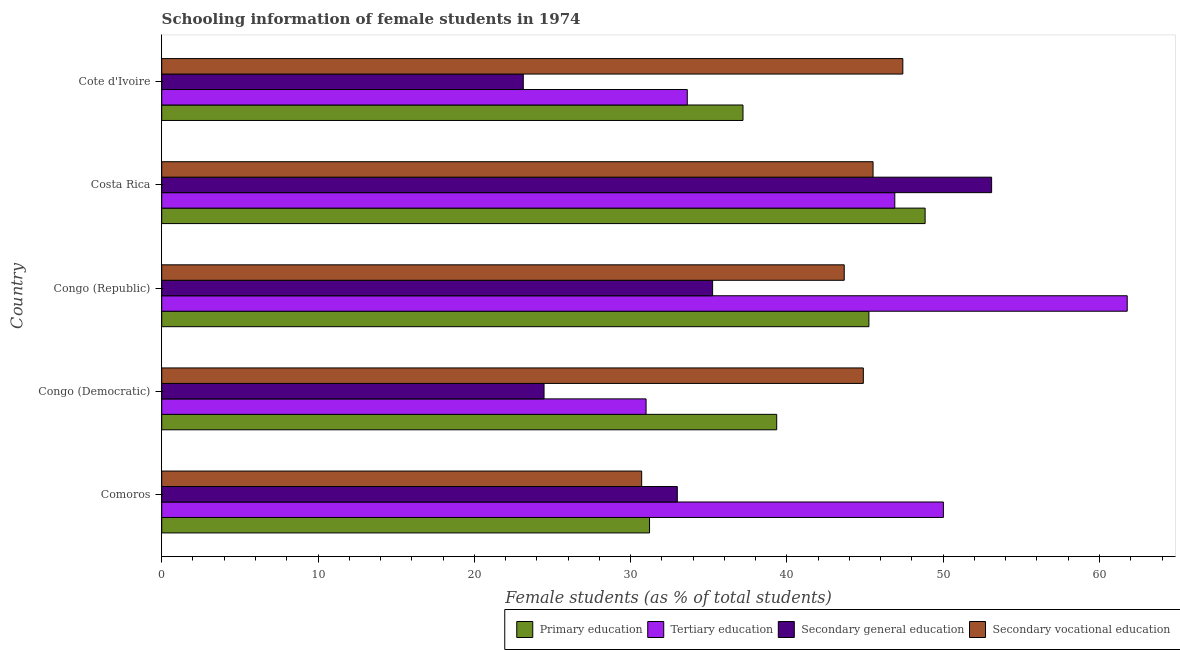How many different coloured bars are there?
Your answer should be compact. 4. How many groups of bars are there?
Offer a very short reply. 5. Are the number of bars per tick equal to the number of legend labels?
Provide a succinct answer. Yes. Are the number of bars on each tick of the Y-axis equal?
Give a very brief answer. Yes. How many bars are there on the 1st tick from the top?
Provide a succinct answer. 4. How many bars are there on the 4th tick from the bottom?
Offer a terse response. 4. What is the label of the 2nd group of bars from the top?
Provide a succinct answer. Costa Rica. What is the percentage of female students in secondary education in Congo (Democratic)?
Your answer should be compact. 24.46. Across all countries, what is the maximum percentage of female students in secondary vocational education?
Offer a terse response. 47.42. Across all countries, what is the minimum percentage of female students in tertiary education?
Ensure brevity in your answer.  30.99. In which country was the percentage of female students in primary education maximum?
Provide a short and direct response. Costa Rica. In which country was the percentage of female students in secondary vocational education minimum?
Your answer should be very brief. Comoros. What is the total percentage of female students in primary education in the graph?
Your response must be concise. 201.84. What is the difference between the percentage of female students in primary education in Comoros and that in Cote d'Ivoire?
Keep it short and to the point. -5.98. What is the difference between the percentage of female students in secondary education in Congo (Democratic) and the percentage of female students in tertiary education in Congo (Republic)?
Provide a succinct answer. -37.31. What is the average percentage of female students in tertiary education per country?
Keep it short and to the point. 44.66. What is the difference between the percentage of female students in primary education and percentage of female students in tertiary education in Congo (Democratic)?
Provide a short and direct response. 8.36. What is the ratio of the percentage of female students in tertiary education in Congo (Democratic) to that in Congo (Republic)?
Your answer should be compact. 0.5. Is the percentage of female students in secondary education in Comoros less than that in Congo (Democratic)?
Ensure brevity in your answer.  No. Is the difference between the percentage of female students in tertiary education in Congo (Republic) and Costa Rica greater than the difference between the percentage of female students in primary education in Congo (Republic) and Costa Rica?
Offer a very short reply. Yes. What is the difference between the highest and the second highest percentage of female students in secondary education?
Ensure brevity in your answer.  17.85. What is the difference between the highest and the lowest percentage of female students in secondary vocational education?
Give a very brief answer. 16.71. In how many countries, is the percentage of female students in secondary vocational education greater than the average percentage of female students in secondary vocational education taken over all countries?
Your answer should be very brief. 4. Is it the case that in every country, the sum of the percentage of female students in secondary vocational education and percentage of female students in tertiary education is greater than the sum of percentage of female students in primary education and percentage of female students in secondary education?
Provide a succinct answer. No. What does the 4th bar from the top in Costa Rica represents?
Provide a succinct answer. Primary education. What does the 3rd bar from the bottom in Cote d'Ivoire represents?
Give a very brief answer. Secondary general education. Is it the case that in every country, the sum of the percentage of female students in primary education and percentage of female students in tertiary education is greater than the percentage of female students in secondary education?
Provide a short and direct response. Yes. How many bars are there?
Your answer should be compact. 20. Are all the bars in the graph horizontal?
Your response must be concise. Yes. How many legend labels are there?
Your response must be concise. 4. What is the title of the graph?
Offer a very short reply. Schooling information of female students in 1974. Does "Services" appear as one of the legend labels in the graph?
Make the answer very short. No. What is the label or title of the X-axis?
Give a very brief answer. Female students (as % of total students). What is the Female students (as % of total students) of Primary education in Comoros?
Provide a short and direct response. 31.21. What is the Female students (as % of total students) of Tertiary education in Comoros?
Offer a very short reply. 50.01. What is the Female students (as % of total students) of Secondary general education in Comoros?
Keep it short and to the point. 32.99. What is the Female students (as % of total students) in Secondary vocational education in Comoros?
Offer a very short reply. 30.71. What is the Female students (as % of total students) in Primary education in Congo (Democratic)?
Keep it short and to the point. 39.35. What is the Female students (as % of total students) of Tertiary education in Congo (Democratic)?
Your response must be concise. 30.99. What is the Female students (as % of total students) of Secondary general education in Congo (Democratic)?
Ensure brevity in your answer.  24.46. What is the Female students (as % of total students) of Secondary vocational education in Congo (Democratic)?
Ensure brevity in your answer.  44.89. What is the Female students (as % of total students) of Primary education in Congo (Republic)?
Give a very brief answer. 45.25. What is the Female students (as % of total students) in Tertiary education in Congo (Republic)?
Provide a short and direct response. 61.77. What is the Female students (as % of total students) of Secondary general education in Congo (Republic)?
Provide a short and direct response. 35.25. What is the Female students (as % of total students) of Secondary vocational education in Congo (Republic)?
Your answer should be very brief. 43.67. What is the Female students (as % of total students) in Primary education in Costa Rica?
Keep it short and to the point. 48.84. What is the Female students (as % of total students) of Tertiary education in Costa Rica?
Give a very brief answer. 46.9. What is the Female students (as % of total students) in Secondary general education in Costa Rica?
Offer a terse response. 53.1. What is the Female students (as % of total students) in Secondary vocational education in Costa Rica?
Your answer should be very brief. 45.51. What is the Female students (as % of total students) in Primary education in Cote d'Ivoire?
Keep it short and to the point. 37.19. What is the Female students (as % of total students) in Tertiary education in Cote d'Ivoire?
Give a very brief answer. 33.63. What is the Female students (as % of total students) in Secondary general education in Cote d'Ivoire?
Your answer should be very brief. 23.13. What is the Female students (as % of total students) of Secondary vocational education in Cote d'Ivoire?
Provide a succinct answer. 47.42. Across all countries, what is the maximum Female students (as % of total students) of Primary education?
Provide a succinct answer. 48.84. Across all countries, what is the maximum Female students (as % of total students) in Tertiary education?
Keep it short and to the point. 61.77. Across all countries, what is the maximum Female students (as % of total students) in Secondary general education?
Offer a very short reply. 53.1. Across all countries, what is the maximum Female students (as % of total students) of Secondary vocational education?
Your response must be concise. 47.42. Across all countries, what is the minimum Female students (as % of total students) in Primary education?
Offer a very short reply. 31.21. Across all countries, what is the minimum Female students (as % of total students) of Tertiary education?
Your answer should be compact. 30.99. Across all countries, what is the minimum Female students (as % of total students) in Secondary general education?
Your response must be concise. 23.13. Across all countries, what is the minimum Female students (as % of total students) in Secondary vocational education?
Your response must be concise. 30.71. What is the total Female students (as % of total students) of Primary education in the graph?
Ensure brevity in your answer.  201.84. What is the total Female students (as % of total students) in Tertiary education in the graph?
Offer a very short reply. 223.3. What is the total Female students (as % of total students) of Secondary general education in the graph?
Your answer should be very brief. 168.93. What is the total Female students (as % of total students) of Secondary vocational education in the graph?
Offer a very short reply. 212.19. What is the difference between the Female students (as % of total students) in Primary education in Comoros and that in Congo (Democratic)?
Your answer should be very brief. -8.14. What is the difference between the Female students (as % of total students) of Tertiary education in Comoros and that in Congo (Democratic)?
Ensure brevity in your answer.  19.02. What is the difference between the Female students (as % of total students) in Secondary general education in Comoros and that in Congo (Democratic)?
Your answer should be very brief. 8.53. What is the difference between the Female students (as % of total students) of Secondary vocational education in Comoros and that in Congo (Democratic)?
Ensure brevity in your answer.  -14.18. What is the difference between the Female students (as % of total students) of Primary education in Comoros and that in Congo (Republic)?
Keep it short and to the point. -14.04. What is the difference between the Female students (as % of total students) in Tertiary education in Comoros and that in Congo (Republic)?
Offer a terse response. -11.76. What is the difference between the Female students (as % of total students) in Secondary general education in Comoros and that in Congo (Republic)?
Provide a succinct answer. -2.26. What is the difference between the Female students (as % of total students) in Secondary vocational education in Comoros and that in Congo (Republic)?
Provide a short and direct response. -12.96. What is the difference between the Female students (as % of total students) in Primary education in Comoros and that in Costa Rica?
Offer a terse response. -17.63. What is the difference between the Female students (as % of total students) in Tertiary education in Comoros and that in Costa Rica?
Provide a succinct answer. 3.11. What is the difference between the Female students (as % of total students) in Secondary general education in Comoros and that in Costa Rica?
Your response must be concise. -20.11. What is the difference between the Female students (as % of total students) in Secondary vocational education in Comoros and that in Costa Rica?
Make the answer very short. -14.8. What is the difference between the Female students (as % of total students) of Primary education in Comoros and that in Cote d'Ivoire?
Provide a succinct answer. -5.98. What is the difference between the Female students (as % of total students) in Tertiary education in Comoros and that in Cote d'Ivoire?
Provide a succinct answer. 16.39. What is the difference between the Female students (as % of total students) in Secondary general education in Comoros and that in Cote d'Ivoire?
Offer a very short reply. 9.85. What is the difference between the Female students (as % of total students) in Secondary vocational education in Comoros and that in Cote d'Ivoire?
Ensure brevity in your answer.  -16.71. What is the difference between the Female students (as % of total students) of Primary education in Congo (Democratic) and that in Congo (Republic)?
Your answer should be very brief. -5.9. What is the difference between the Female students (as % of total students) of Tertiary education in Congo (Democratic) and that in Congo (Republic)?
Provide a succinct answer. -30.78. What is the difference between the Female students (as % of total students) of Secondary general education in Congo (Democratic) and that in Congo (Republic)?
Provide a succinct answer. -10.79. What is the difference between the Female students (as % of total students) of Secondary vocational education in Congo (Democratic) and that in Congo (Republic)?
Give a very brief answer. 1.22. What is the difference between the Female students (as % of total students) of Primary education in Congo (Democratic) and that in Costa Rica?
Make the answer very short. -9.5. What is the difference between the Female students (as % of total students) of Tertiary education in Congo (Democratic) and that in Costa Rica?
Provide a succinct answer. -15.91. What is the difference between the Female students (as % of total students) in Secondary general education in Congo (Democratic) and that in Costa Rica?
Ensure brevity in your answer.  -28.64. What is the difference between the Female students (as % of total students) of Secondary vocational education in Congo (Democratic) and that in Costa Rica?
Make the answer very short. -0.62. What is the difference between the Female students (as % of total students) of Primary education in Congo (Democratic) and that in Cote d'Ivoire?
Your response must be concise. 2.16. What is the difference between the Female students (as % of total students) of Tertiary education in Congo (Democratic) and that in Cote d'Ivoire?
Ensure brevity in your answer.  -2.64. What is the difference between the Female students (as % of total students) in Secondary general education in Congo (Democratic) and that in Cote d'Ivoire?
Your answer should be very brief. 1.33. What is the difference between the Female students (as % of total students) in Secondary vocational education in Congo (Democratic) and that in Cote d'Ivoire?
Your answer should be compact. -2.53. What is the difference between the Female students (as % of total students) of Primary education in Congo (Republic) and that in Costa Rica?
Give a very brief answer. -3.6. What is the difference between the Female students (as % of total students) of Tertiary education in Congo (Republic) and that in Costa Rica?
Ensure brevity in your answer.  14.87. What is the difference between the Female students (as % of total students) of Secondary general education in Congo (Republic) and that in Costa Rica?
Ensure brevity in your answer.  -17.85. What is the difference between the Female students (as % of total students) in Secondary vocational education in Congo (Republic) and that in Costa Rica?
Provide a succinct answer. -1.84. What is the difference between the Female students (as % of total students) of Primary education in Congo (Republic) and that in Cote d'Ivoire?
Ensure brevity in your answer.  8.06. What is the difference between the Female students (as % of total students) of Tertiary education in Congo (Republic) and that in Cote d'Ivoire?
Make the answer very short. 28.15. What is the difference between the Female students (as % of total students) in Secondary general education in Congo (Republic) and that in Cote d'Ivoire?
Make the answer very short. 12.11. What is the difference between the Female students (as % of total students) of Secondary vocational education in Congo (Republic) and that in Cote d'Ivoire?
Ensure brevity in your answer.  -3.75. What is the difference between the Female students (as % of total students) of Primary education in Costa Rica and that in Cote d'Ivoire?
Keep it short and to the point. 11.65. What is the difference between the Female students (as % of total students) in Tertiary education in Costa Rica and that in Cote d'Ivoire?
Make the answer very short. 13.28. What is the difference between the Female students (as % of total students) of Secondary general education in Costa Rica and that in Cote d'Ivoire?
Offer a terse response. 29.96. What is the difference between the Female students (as % of total students) in Secondary vocational education in Costa Rica and that in Cote d'Ivoire?
Your response must be concise. -1.9. What is the difference between the Female students (as % of total students) in Primary education in Comoros and the Female students (as % of total students) in Tertiary education in Congo (Democratic)?
Give a very brief answer. 0.22. What is the difference between the Female students (as % of total students) of Primary education in Comoros and the Female students (as % of total students) of Secondary general education in Congo (Democratic)?
Give a very brief answer. 6.75. What is the difference between the Female students (as % of total students) in Primary education in Comoros and the Female students (as % of total students) in Secondary vocational education in Congo (Democratic)?
Provide a succinct answer. -13.68. What is the difference between the Female students (as % of total students) in Tertiary education in Comoros and the Female students (as % of total students) in Secondary general education in Congo (Democratic)?
Provide a succinct answer. 25.55. What is the difference between the Female students (as % of total students) of Tertiary education in Comoros and the Female students (as % of total students) of Secondary vocational education in Congo (Democratic)?
Offer a terse response. 5.12. What is the difference between the Female students (as % of total students) of Secondary general education in Comoros and the Female students (as % of total students) of Secondary vocational education in Congo (Democratic)?
Ensure brevity in your answer.  -11.9. What is the difference between the Female students (as % of total students) of Primary education in Comoros and the Female students (as % of total students) of Tertiary education in Congo (Republic)?
Offer a terse response. -30.56. What is the difference between the Female students (as % of total students) in Primary education in Comoros and the Female students (as % of total students) in Secondary general education in Congo (Republic)?
Your answer should be very brief. -4.04. What is the difference between the Female students (as % of total students) of Primary education in Comoros and the Female students (as % of total students) of Secondary vocational education in Congo (Republic)?
Your answer should be compact. -12.46. What is the difference between the Female students (as % of total students) of Tertiary education in Comoros and the Female students (as % of total students) of Secondary general education in Congo (Republic)?
Ensure brevity in your answer.  14.76. What is the difference between the Female students (as % of total students) of Tertiary education in Comoros and the Female students (as % of total students) of Secondary vocational education in Congo (Republic)?
Make the answer very short. 6.34. What is the difference between the Female students (as % of total students) of Secondary general education in Comoros and the Female students (as % of total students) of Secondary vocational education in Congo (Republic)?
Make the answer very short. -10.68. What is the difference between the Female students (as % of total students) of Primary education in Comoros and the Female students (as % of total students) of Tertiary education in Costa Rica?
Offer a terse response. -15.69. What is the difference between the Female students (as % of total students) in Primary education in Comoros and the Female students (as % of total students) in Secondary general education in Costa Rica?
Make the answer very short. -21.89. What is the difference between the Female students (as % of total students) of Primary education in Comoros and the Female students (as % of total students) of Secondary vocational education in Costa Rica?
Your response must be concise. -14.3. What is the difference between the Female students (as % of total students) of Tertiary education in Comoros and the Female students (as % of total students) of Secondary general education in Costa Rica?
Make the answer very short. -3.09. What is the difference between the Female students (as % of total students) in Tertiary education in Comoros and the Female students (as % of total students) in Secondary vocational education in Costa Rica?
Provide a short and direct response. 4.5. What is the difference between the Female students (as % of total students) of Secondary general education in Comoros and the Female students (as % of total students) of Secondary vocational education in Costa Rica?
Make the answer very short. -12.52. What is the difference between the Female students (as % of total students) in Primary education in Comoros and the Female students (as % of total students) in Tertiary education in Cote d'Ivoire?
Your response must be concise. -2.42. What is the difference between the Female students (as % of total students) of Primary education in Comoros and the Female students (as % of total students) of Secondary general education in Cote d'Ivoire?
Provide a short and direct response. 8.08. What is the difference between the Female students (as % of total students) in Primary education in Comoros and the Female students (as % of total students) in Secondary vocational education in Cote d'Ivoire?
Offer a terse response. -16.21. What is the difference between the Female students (as % of total students) in Tertiary education in Comoros and the Female students (as % of total students) in Secondary general education in Cote d'Ivoire?
Give a very brief answer. 26.88. What is the difference between the Female students (as % of total students) in Tertiary education in Comoros and the Female students (as % of total students) in Secondary vocational education in Cote d'Ivoire?
Your answer should be compact. 2.59. What is the difference between the Female students (as % of total students) in Secondary general education in Comoros and the Female students (as % of total students) in Secondary vocational education in Cote d'Ivoire?
Provide a short and direct response. -14.43. What is the difference between the Female students (as % of total students) in Primary education in Congo (Democratic) and the Female students (as % of total students) in Tertiary education in Congo (Republic)?
Ensure brevity in your answer.  -22.43. What is the difference between the Female students (as % of total students) of Primary education in Congo (Democratic) and the Female students (as % of total students) of Secondary general education in Congo (Republic)?
Make the answer very short. 4.1. What is the difference between the Female students (as % of total students) in Primary education in Congo (Democratic) and the Female students (as % of total students) in Secondary vocational education in Congo (Republic)?
Offer a very short reply. -4.32. What is the difference between the Female students (as % of total students) of Tertiary education in Congo (Democratic) and the Female students (as % of total students) of Secondary general education in Congo (Republic)?
Your answer should be compact. -4.26. What is the difference between the Female students (as % of total students) of Tertiary education in Congo (Democratic) and the Female students (as % of total students) of Secondary vocational education in Congo (Republic)?
Your answer should be compact. -12.68. What is the difference between the Female students (as % of total students) in Secondary general education in Congo (Democratic) and the Female students (as % of total students) in Secondary vocational education in Congo (Republic)?
Make the answer very short. -19.21. What is the difference between the Female students (as % of total students) of Primary education in Congo (Democratic) and the Female students (as % of total students) of Tertiary education in Costa Rica?
Ensure brevity in your answer.  -7.56. What is the difference between the Female students (as % of total students) in Primary education in Congo (Democratic) and the Female students (as % of total students) in Secondary general education in Costa Rica?
Ensure brevity in your answer.  -13.75. What is the difference between the Female students (as % of total students) of Primary education in Congo (Democratic) and the Female students (as % of total students) of Secondary vocational education in Costa Rica?
Make the answer very short. -6.17. What is the difference between the Female students (as % of total students) in Tertiary education in Congo (Democratic) and the Female students (as % of total students) in Secondary general education in Costa Rica?
Keep it short and to the point. -22.11. What is the difference between the Female students (as % of total students) in Tertiary education in Congo (Democratic) and the Female students (as % of total students) in Secondary vocational education in Costa Rica?
Provide a short and direct response. -14.52. What is the difference between the Female students (as % of total students) of Secondary general education in Congo (Democratic) and the Female students (as % of total students) of Secondary vocational education in Costa Rica?
Offer a very short reply. -21.05. What is the difference between the Female students (as % of total students) of Primary education in Congo (Democratic) and the Female students (as % of total students) of Tertiary education in Cote d'Ivoire?
Provide a short and direct response. 5.72. What is the difference between the Female students (as % of total students) of Primary education in Congo (Democratic) and the Female students (as % of total students) of Secondary general education in Cote d'Ivoire?
Make the answer very short. 16.21. What is the difference between the Female students (as % of total students) of Primary education in Congo (Democratic) and the Female students (as % of total students) of Secondary vocational education in Cote d'Ivoire?
Provide a short and direct response. -8.07. What is the difference between the Female students (as % of total students) of Tertiary education in Congo (Democratic) and the Female students (as % of total students) of Secondary general education in Cote d'Ivoire?
Offer a terse response. 7.86. What is the difference between the Female students (as % of total students) of Tertiary education in Congo (Democratic) and the Female students (as % of total students) of Secondary vocational education in Cote d'Ivoire?
Your answer should be compact. -16.43. What is the difference between the Female students (as % of total students) of Secondary general education in Congo (Democratic) and the Female students (as % of total students) of Secondary vocational education in Cote d'Ivoire?
Make the answer very short. -22.96. What is the difference between the Female students (as % of total students) of Primary education in Congo (Republic) and the Female students (as % of total students) of Tertiary education in Costa Rica?
Ensure brevity in your answer.  -1.66. What is the difference between the Female students (as % of total students) in Primary education in Congo (Republic) and the Female students (as % of total students) in Secondary general education in Costa Rica?
Provide a succinct answer. -7.85. What is the difference between the Female students (as % of total students) of Primary education in Congo (Republic) and the Female students (as % of total students) of Secondary vocational education in Costa Rica?
Your answer should be compact. -0.27. What is the difference between the Female students (as % of total students) of Tertiary education in Congo (Republic) and the Female students (as % of total students) of Secondary general education in Costa Rica?
Your answer should be very brief. 8.68. What is the difference between the Female students (as % of total students) of Tertiary education in Congo (Republic) and the Female students (as % of total students) of Secondary vocational education in Costa Rica?
Provide a succinct answer. 16.26. What is the difference between the Female students (as % of total students) in Secondary general education in Congo (Republic) and the Female students (as % of total students) in Secondary vocational education in Costa Rica?
Give a very brief answer. -10.27. What is the difference between the Female students (as % of total students) of Primary education in Congo (Republic) and the Female students (as % of total students) of Tertiary education in Cote d'Ivoire?
Provide a short and direct response. 11.62. What is the difference between the Female students (as % of total students) of Primary education in Congo (Republic) and the Female students (as % of total students) of Secondary general education in Cote d'Ivoire?
Keep it short and to the point. 22.11. What is the difference between the Female students (as % of total students) in Primary education in Congo (Republic) and the Female students (as % of total students) in Secondary vocational education in Cote d'Ivoire?
Offer a very short reply. -2.17. What is the difference between the Female students (as % of total students) of Tertiary education in Congo (Republic) and the Female students (as % of total students) of Secondary general education in Cote d'Ivoire?
Offer a terse response. 38.64. What is the difference between the Female students (as % of total students) in Tertiary education in Congo (Republic) and the Female students (as % of total students) in Secondary vocational education in Cote d'Ivoire?
Make the answer very short. 14.36. What is the difference between the Female students (as % of total students) in Secondary general education in Congo (Republic) and the Female students (as % of total students) in Secondary vocational education in Cote d'Ivoire?
Make the answer very short. -12.17. What is the difference between the Female students (as % of total students) in Primary education in Costa Rica and the Female students (as % of total students) in Tertiary education in Cote d'Ivoire?
Your response must be concise. 15.22. What is the difference between the Female students (as % of total students) in Primary education in Costa Rica and the Female students (as % of total students) in Secondary general education in Cote d'Ivoire?
Ensure brevity in your answer.  25.71. What is the difference between the Female students (as % of total students) of Primary education in Costa Rica and the Female students (as % of total students) of Secondary vocational education in Cote d'Ivoire?
Give a very brief answer. 1.43. What is the difference between the Female students (as % of total students) in Tertiary education in Costa Rica and the Female students (as % of total students) in Secondary general education in Cote d'Ivoire?
Your response must be concise. 23.77. What is the difference between the Female students (as % of total students) of Tertiary education in Costa Rica and the Female students (as % of total students) of Secondary vocational education in Cote d'Ivoire?
Your answer should be compact. -0.51. What is the difference between the Female students (as % of total students) of Secondary general education in Costa Rica and the Female students (as % of total students) of Secondary vocational education in Cote d'Ivoire?
Make the answer very short. 5.68. What is the average Female students (as % of total students) of Primary education per country?
Make the answer very short. 40.37. What is the average Female students (as % of total students) of Tertiary education per country?
Give a very brief answer. 44.66. What is the average Female students (as % of total students) in Secondary general education per country?
Your response must be concise. 33.79. What is the average Female students (as % of total students) of Secondary vocational education per country?
Your answer should be very brief. 42.44. What is the difference between the Female students (as % of total students) in Primary education and Female students (as % of total students) in Tertiary education in Comoros?
Your answer should be very brief. -18.8. What is the difference between the Female students (as % of total students) of Primary education and Female students (as % of total students) of Secondary general education in Comoros?
Make the answer very short. -1.78. What is the difference between the Female students (as % of total students) in Primary education and Female students (as % of total students) in Secondary vocational education in Comoros?
Your answer should be very brief. 0.5. What is the difference between the Female students (as % of total students) in Tertiary education and Female students (as % of total students) in Secondary general education in Comoros?
Your response must be concise. 17.02. What is the difference between the Female students (as % of total students) in Tertiary education and Female students (as % of total students) in Secondary vocational education in Comoros?
Your response must be concise. 19.3. What is the difference between the Female students (as % of total students) in Secondary general education and Female students (as % of total students) in Secondary vocational education in Comoros?
Give a very brief answer. 2.28. What is the difference between the Female students (as % of total students) of Primary education and Female students (as % of total students) of Tertiary education in Congo (Democratic)?
Make the answer very short. 8.36. What is the difference between the Female students (as % of total students) in Primary education and Female students (as % of total students) in Secondary general education in Congo (Democratic)?
Give a very brief answer. 14.89. What is the difference between the Female students (as % of total students) in Primary education and Female students (as % of total students) in Secondary vocational education in Congo (Democratic)?
Give a very brief answer. -5.54. What is the difference between the Female students (as % of total students) of Tertiary education and Female students (as % of total students) of Secondary general education in Congo (Democratic)?
Provide a succinct answer. 6.53. What is the difference between the Female students (as % of total students) in Tertiary education and Female students (as % of total students) in Secondary vocational education in Congo (Democratic)?
Your response must be concise. -13.9. What is the difference between the Female students (as % of total students) of Secondary general education and Female students (as % of total students) of Secondary vocational education in Congo (Democratic)?
Offer a very short reply. -20.43. What is the difference between the Female students (as % of total students) of Primary education and Female students (as % of total students) of Tertiary education in Congo (Republic)?
Give a very brief answer. -16.53. What is the difference between the Female students (as % of total students) of Primary education and Female students (as % of total students) of Secondary general education in Congo (Republic)?
Give a very brief answer. 10. What is the difference between the Female students (as % of total students) of Primary education and Female students (as % of total students) of Secondary vocational education in Congo (Republic)?
Keep it short and to the point. 1.58. What is the difference between the Female students (as % of total students) in Tertiary education and Female students (as % of total students) in Secondary general education in Congo (Republic)?
Offer a terse response. 26.53. What is the difference between the Female students (as % of total students) of Tertiary education and Female students (as % of total students) of Secondary vocational education in Congo (Republic)?
Give a very brief answer. 18.11. What is the difference between the Female students (as % of total students) in Secondary general education and Female students (as % of total students) in Secondary vocational education in Congo (Republic)?
Your answer should be compact. -8.42. What is the difference between the Female students (as % of total students) of Primary education and Female students (as % of total students) of Tertiary education in Costa Rica?
Offer a very short reply. 1.94. What is the difference between the Female students (as % of total students) of Primary education and Female students (as % of total students) of Secondary general education in Costa Rica?
Your answer should be very brief. -4.26. What is the difference between the Female students (as % of total students) in Primary education and Female students (as % of total students) in Secondary vocational education in Costa Rica?
Offer a terse response. 3.33. What is the difference between the Female students (as % of total students) in Tertiary education and Female students (as % of total students) in Secondary general education in Costa Rica?
Provide a succinct answer. -6.19. What is the difference between the Female students (as % of total students) in Tertiary education and Female students (as % of total students) in Secondary vocational education in Costa Rica?
Offer a terse response. 1.39. What is the difference between the Female students (as % of total students) in Secondary general education and Female students (as % of total students) in Secondary vocational education in Costa Rica?
Your response must be concise. 7.59. What is the difference between the Female students (as % of total students) of Primary education and Female students (as % of total students) of Tertiary education in Cote d'Ivoire?
Provide a short and direct response. 3.56. What is the difference between the Female students (as % of total students) in Primary education and Female students (as % of total students) in Secondary general education in Cote d'Ivoire?
Your response must be concise. 14.06. What is the difference between the Female students (as % of total students) in Primary education and Female students (as % of total students) in Secondary vocational education in Cote d'Ivoire?
Your answer should be compact. -10.23. What is the difference between the Female students (as % of total students) in Tertiary education and Female students (as % of total students) in Secondary general education in Cote d'Ivoire?
Provide a short and direct response. 10.49. What is the difference between the Female students (as % of total students) in Tertiary education and Female students (as % of total students) in Secondary vocational education in Cote d'Ivoire?
Provide a succinct answer. -13.79. What is the difference between the Female students (as % of total students) of Secondary general education and Female students (as % of total students) of Secondary vocational education in Cote d'Ivoire?
Make the answer very short. -24.28. What is the ratio of the Female students (as % of total students) in Primary education in Comoros to that in Congo (Democratic)?
Provide a succinct answer. 0.79. What is the ratio of the Female students (as % of total students) in Tertiary education in Comoros to that in Congo (Democratic)?
Your answer should be very brief. 1.61. What is the ratio of the Female students (as % of total students) of Secondary general education in Comoros to that in Congo (Democratic)?
Ensure brevity in your answer.  1.35. What is the ratio of the Female students (as % of total students) of Secondary vocational education in Comoros to that in Congo (Democratic)?
Your answer should be very brief. 0.68. What is the ratio of the Female students (as % of total students) of Primary education in Comoros to that in Congo (Republic)?
Provide a short and direct response. 0.69. What is the ratio of the Female students (as % of total students) in Tertiary education in Comoros to that in Congo (Republic)?
Provide a succinct answer. 0.81. What is the ratio of the Female students (as % of total students) of Secondary general education in Comoros to that in Congo (Republic)?
Your answer should be very brief. 0.94. What is the ratio of the Female students (as % of total students) of Secondary vocational education in Comoros to that in Congo (Republic)?
Provide a succinct answer. 0.7. What is the ratio of the Female students (as % of total students) of Primary education in Comoros to that in Costa Rica?
Your answer should be compact. 0.64. What is the ratio of the Female students (as % of total students) in Tertiary education in Comoros to that in Costa Rica?
Provide a succinct answer. 1.07. What is the ratio of the Female students (as % of total students) of Secondary general education in Comoros to that in Costa Rica?
Your response must be concise. 0.62. What is the ratio of the Female students (as % of total students) in Secondary vocational education in Comoros to that in Costa Rica?
Provide a succinct answer. 0.67. What is the ratio of the Female students (as % of total students) of Primary education in Comoros to that in Cote d'Ivoire?
Make the answer very short. 0.84. What is the ratio of the Female students (as % of total students) of Tertiary education in Comoros to that in Cote d'Ivoire?
Your response must be concise. 1.49. What is the ratio of the Female students (as % of total students) of Secondary general education in Comoros to that in Cote d'Ivoire?
Your response must be concise. 1.43. What is the ratio of the Female students (as % of total students) of Secondary vocational education in Comoros to that in Cote d'Ivoire?
Your answer should be compact. 0.65. What is the ratio of the Female students (as % of total students) in Primary education in Congo (Democratic) to that in Congo (Republic)?
Provide a succinct answer. 0.87. What is the ratio of the Female students (as % of total students) of Tertiary education in Congo (Democratic) to that in Congo (Republic)?
Keep it short and to the point. 0.5. What is the ratio of the Female students (as % of total students) in Secondary general education in Congo (Democratic) to that in Congo (Republic)?
Keep it short and to the point. 0.69. What is the ratio of the Female students (as % of total students) of Secondary vocational education in Congo (Democratic) to that in Congo (Republic)?
Your answer should be very brief. 1.03. What is the ratio of the Female students (as % of total students) in Primary education in Congo (Democratic) to that in Costa Rica?
Your answer should be compact. 0.81. What is the ratio of the Female students (as % of total students) in Tertiary education in Congo (Democratic) to that in Costa Rica?
Give a very brief answer. 0.66. What is the ratio of the Female students (as % of total students) of Secondary general education in Congo (Democratic) to that in Costa Rica?
Provide a short and direct response. 0.46. What is the ratio of the Female students (as % of total students) in Secondary vocational education in Congo (Democratic) to that in Costa Rica?
Your answer should be compact. 0.99. What is the ratio of the Female students (as % of total students) in Primary education in Congo (Democratic) to that in Cote d'Ivoire?
Offer a terse response. 1.06. What is the ratio of the Female students (as % of total students) of Tertiary education in Congo (Democratic) to that in Cote d'Ivoire?
Offer a very short reply. 0.92. What is the ratio of the Female students (as % of total students) in Secondary general education in Congo (Democratic) to that in Cote d'Ivoire?
Your answer should be compact. 1.06. What is the ratio of the Female students (as % of total students) in Secondary vocational education in Congo (Democratic) to that in Cote d'Ivoire?
Provide a short and direct response. 0.95. What is the ratio of the Female students (as % of total students) in Primary education in Congo (Republic) to that in Costa Rica?
Your answer should be very brief. 0.93. What is the ratio of the Female students (as % of total students) of Tertiary education in Congo (Republic) to that in Costa Rica?
Your answer should be very brief. 1.32. What is the ratio of the Female students (as % of total students) in Secondary general education in Congo (Republic) to that in Costa Rica?
Provide a short and direct response. 0.66. What is the ratio of the Female students (as % of total students) in Secondary vocational education in Congo (Republic) to that in Costa Rica?
Keep it short and to the point. 0.96. What is the ratio of the Female students (as % of total students) of Primary education in Congo (Republic) to that in Cote d'Ivoire?
Provide a short and direct response. 1.22. What is the ratio of the Female students (as % of total students) in Tertiary education in Congo (Republic) to that in Cote d'Ivoire?
Provide a succinct answer. 1.84. What is the ratio of the Female students (as % of total students) of Secondary general education in Congo (Republic) to that in Cote d'Ivoire?
Provide a short and direct response. 1.52. What is the ratio of the Female students (as % of total students) of Secondary vocational education in Congo (Republic) to that in Cote d'Ivoire?
Ensure brevity in your answer.  0.92. What is the ratio of the Female students (as % of total students) in Primary education in Costa Rica to that in Cote d'Ivoire?
Provide a succinct answer. 1.31. What is the ratio of the Female students (as % of total students) in Tertiary education in Costa Rica to that in Cote d'Ivoire?
Ensure brevity in your answer.  1.39. What is the ratio of the Female students (as % of total students) of Secondary general education in Costa Rica to that in Cote d'Ivoire?
Your answer should be compact. 2.3. What is the ratio of the Female students (as % of total students) in Secondary vocational education in Costa Rica to that in Cote d'Ivoire?
Make the answer very short. 0.96. What is the difference between the highest and the second highest Female students (as % of total students) in Primary education?
Offer a terse response. 3.6. What is the difference between the highest and the second highest Female students (as % of total students) in Tertiary education?
Ensure brevity in your answer.  11.76. What is the difference between the highest and the second highest Female students (as % of total students) of Secondary general education?
Provide a short and direct response. 17.85. What is the difference between the highest and the second highest Female students (as % of total students) in Secondary vocational education?
Ensure brevity in your answer.  1.9. What is the difference between the highest and the lowest Female students (as % of total students) in Primary education?
Make the answer very short. 17.63. What is the difference between the highest and the lowest Female students (as % of total students) in Tertiary education?
Ensure brevity in your answer.  30.78. What is the difference between the highest and the lowest Female students (as % of total students) in Secondary general education?
Offer a very short reply. 29.96. What is the difference between the highest and the lowest Female students (as % of total students) of Secondary vocational education?
Keep it short and to the point. 16.71. 